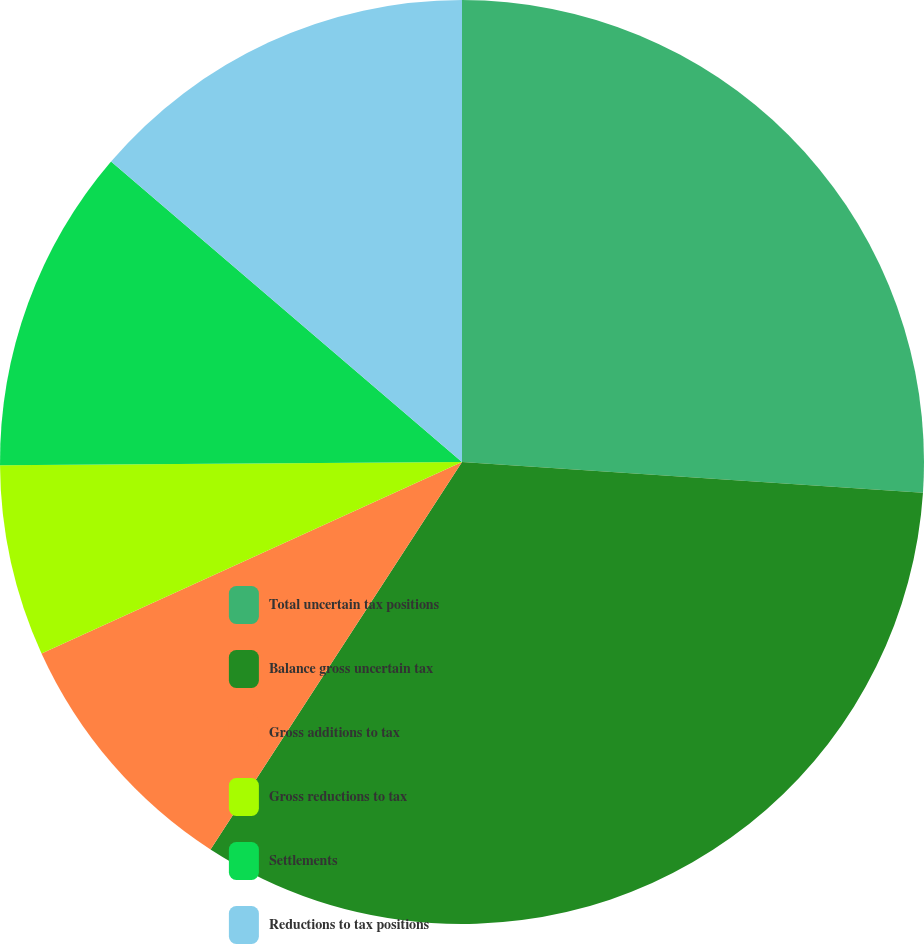Convert chart. <chart><loc_0><loc_0><loc_500><loc_500><pie_chart><fcel>Total uncertain tax positions<fcel>Balance gross uncertain tax<fcel>Gross additions to tax<fcel>Gross reductions to tax<fcel>Settlements<fcel>Reductions to tax positions<nl><fcel>26.06%<fcel>33.1%<fcel>9.04%<fcel>6.69%<fcel>11.38%<fcel>13.73%<nl></chart> 